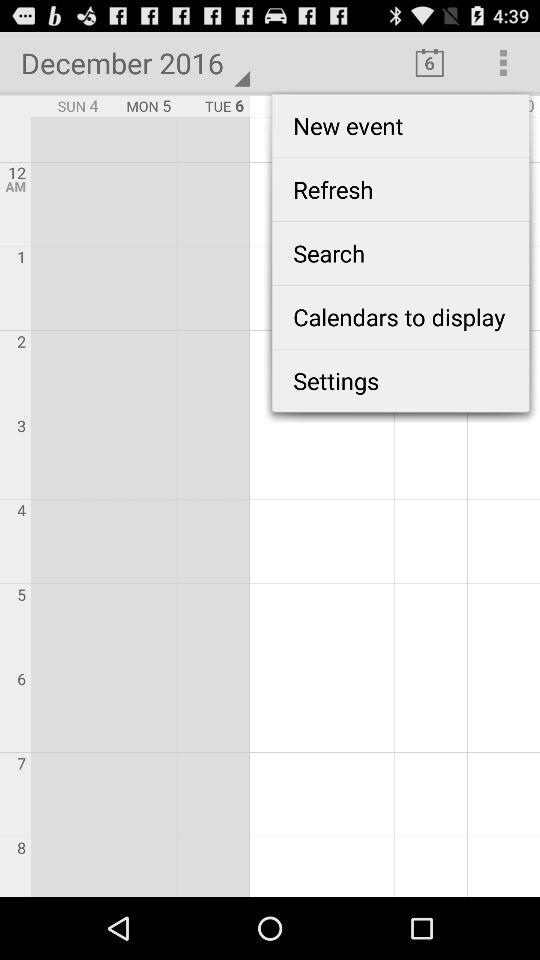What is the selected date?
When the provided information is insufficient, respond with <no answer>. <no answer> 